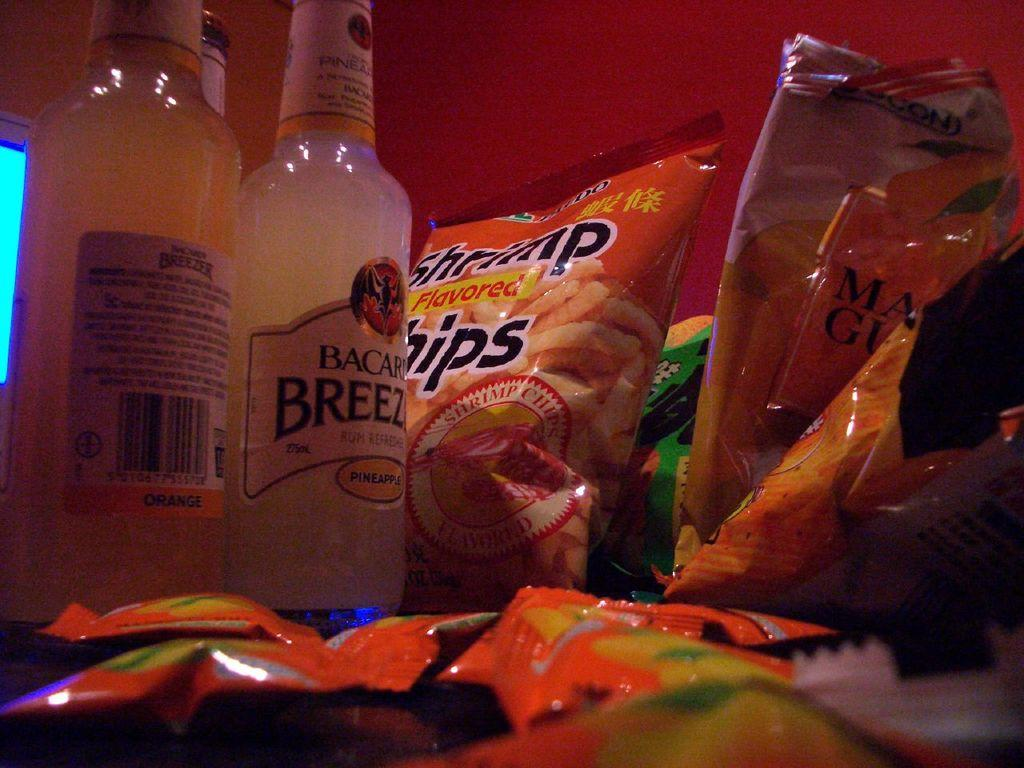Provide a one-sentence caption for the provided image. A couple of bottles of Bacardi Breeze next to bags of Shrimp Flavored Chips. 